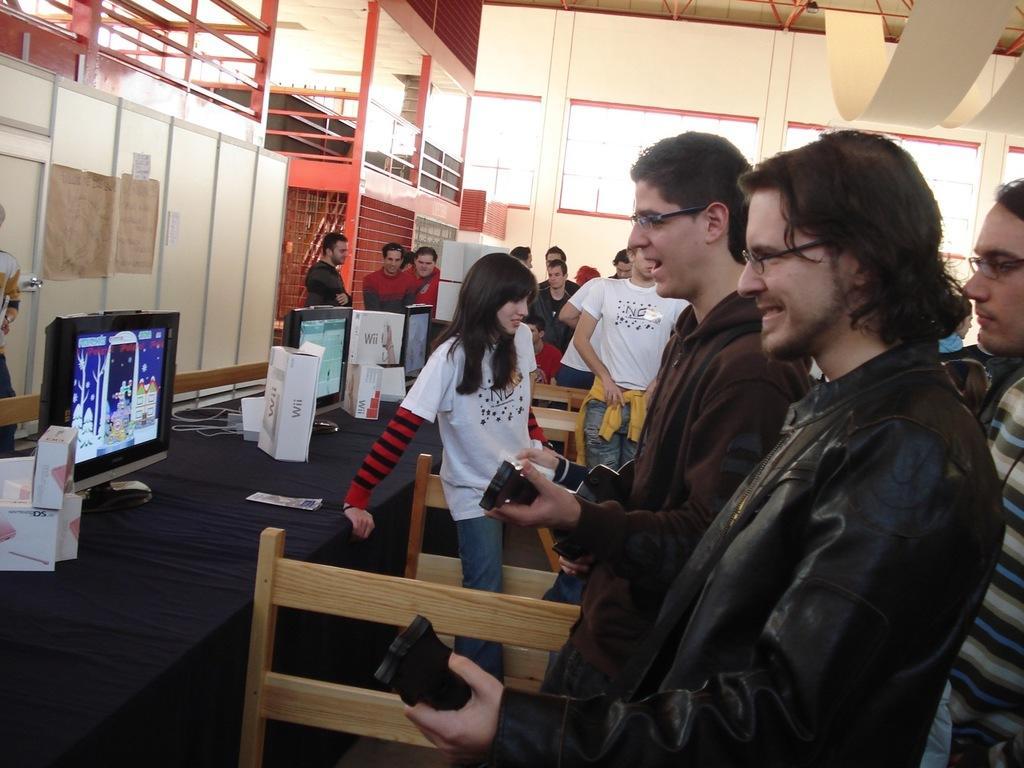Please provide a concise description of this image. In this image I can see people among them these men are holding some objects in hands. Here I can see a table. On the table I can see monitors, boxes and other objects on it. In the background I can see a wall and other objects. 